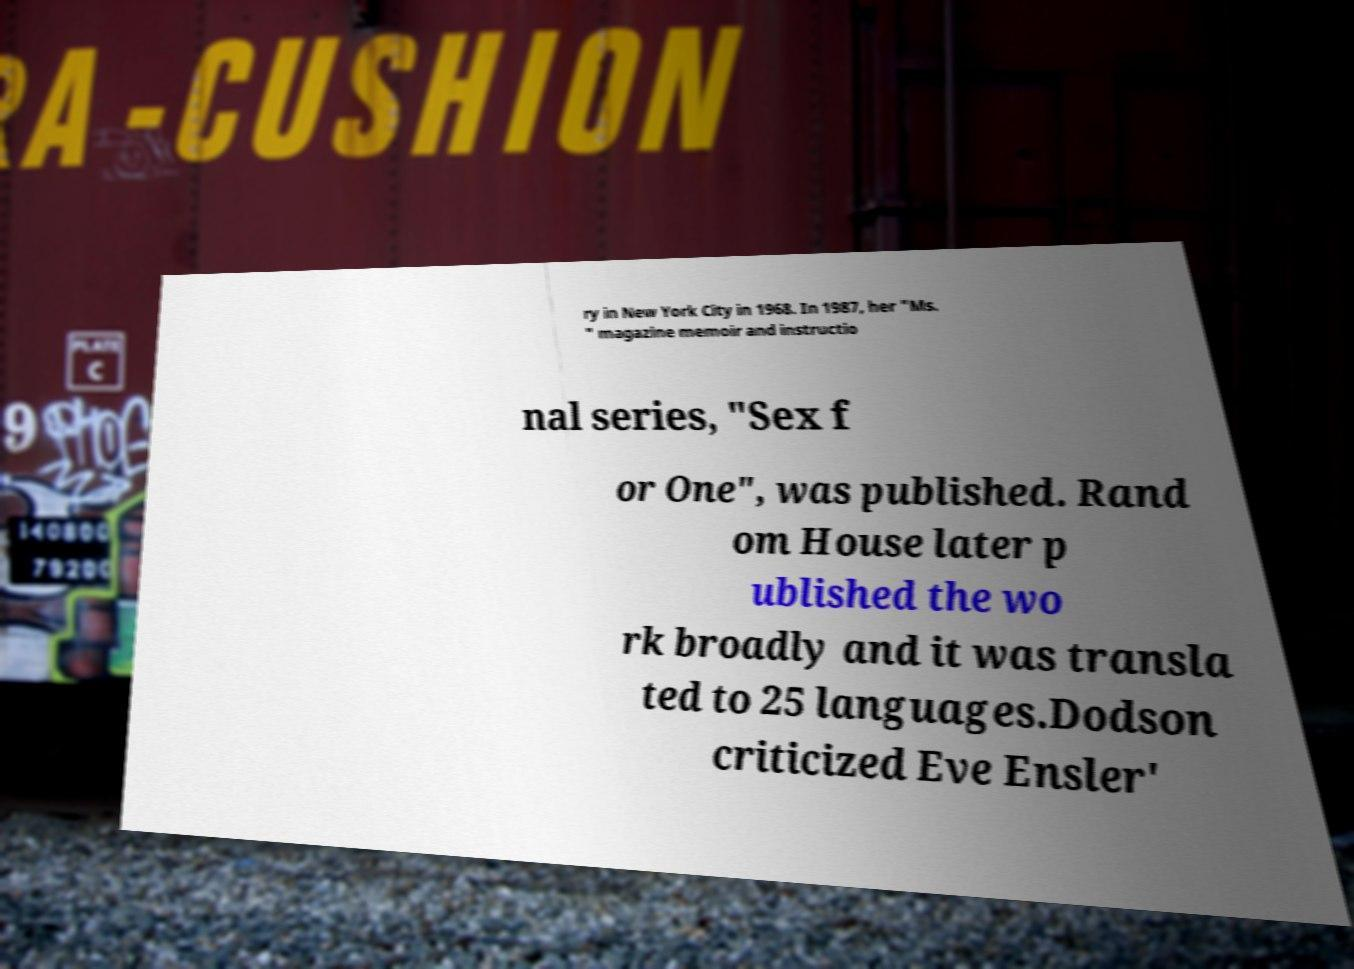For documentation purposes, I need the text within this image transcribed. Could you provide that? ry in New York City in 1968. In 1987, her "Ms. " magazine memoir and instructio nal series, "Sex f or One", was published. Rand om House later p ublished the wo rk broadly and it was transla ted to 25 languages.Dodson criticized Eve Ensler' 